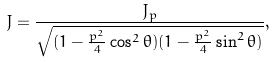<formula> <loc_0><loc_0><loc_500><loc_500>J = \frac { J _ { p } } { \sqrt { ( 1 - \frac { p ^ { 2 } } { 4 } \cos ^ { 2 } \theta ) ( 1 - \frac { p ^ { 2 } } { 4 } \sin ^ { 2 } \theta ) } } ,</formula> 